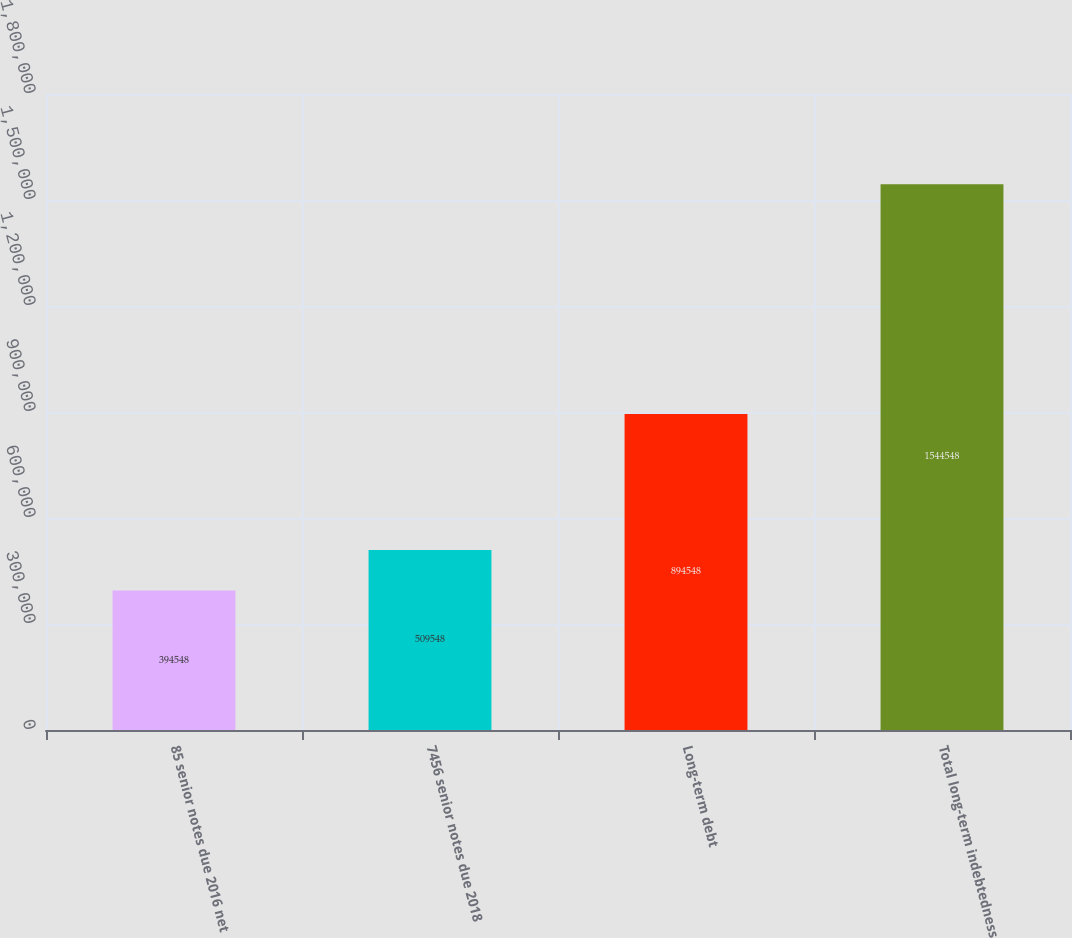Convert chart to OTSL. <chart><loc_0><loc_0><loc_500><loc_500><bar_chart><fcel>85 senior notes due 2016 net<fcel>7456 senior notes due 2018<fcel>Long-term debt<fcel>Total long-term indebtedness<nl><fcel>394548<fcel>509548<fcel>894548<fcel>1.54455e+06<nl></chart> 